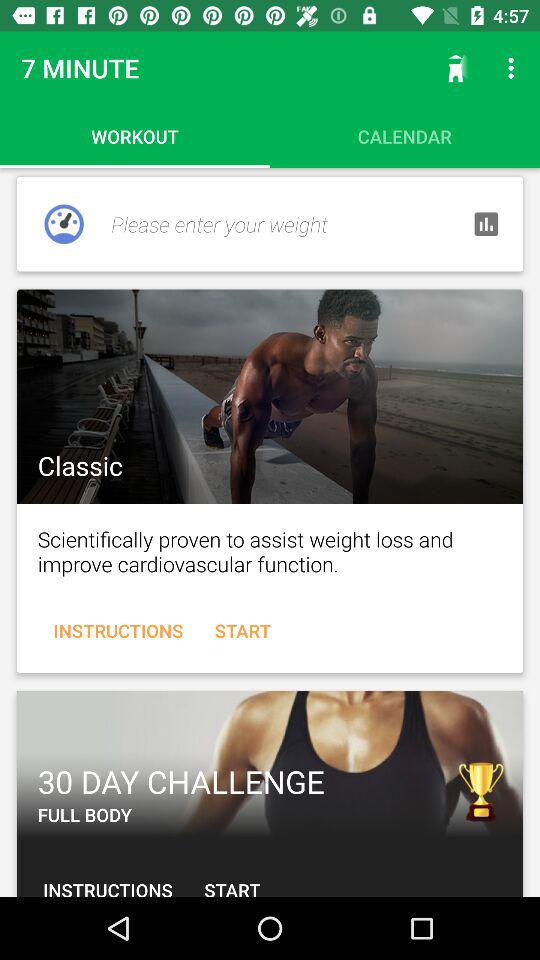Which tab is selected? The selected tab is "WORKOUT". 